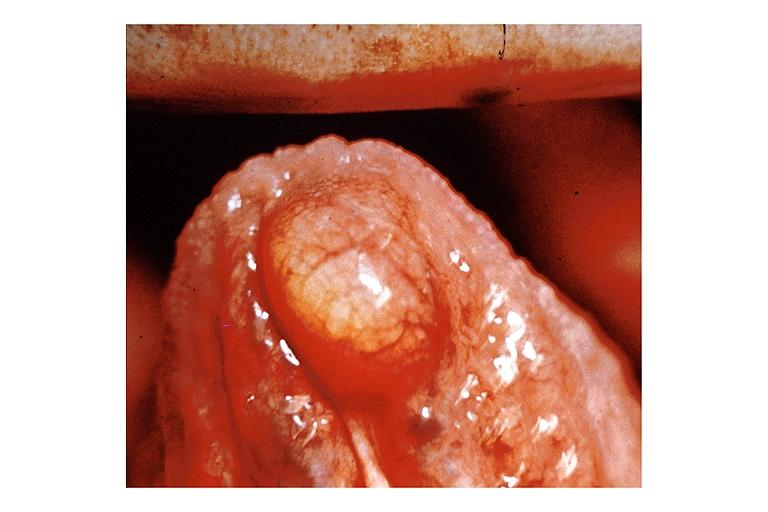what does this image show?
Answer the question using a single word or phrase. Lipoma 